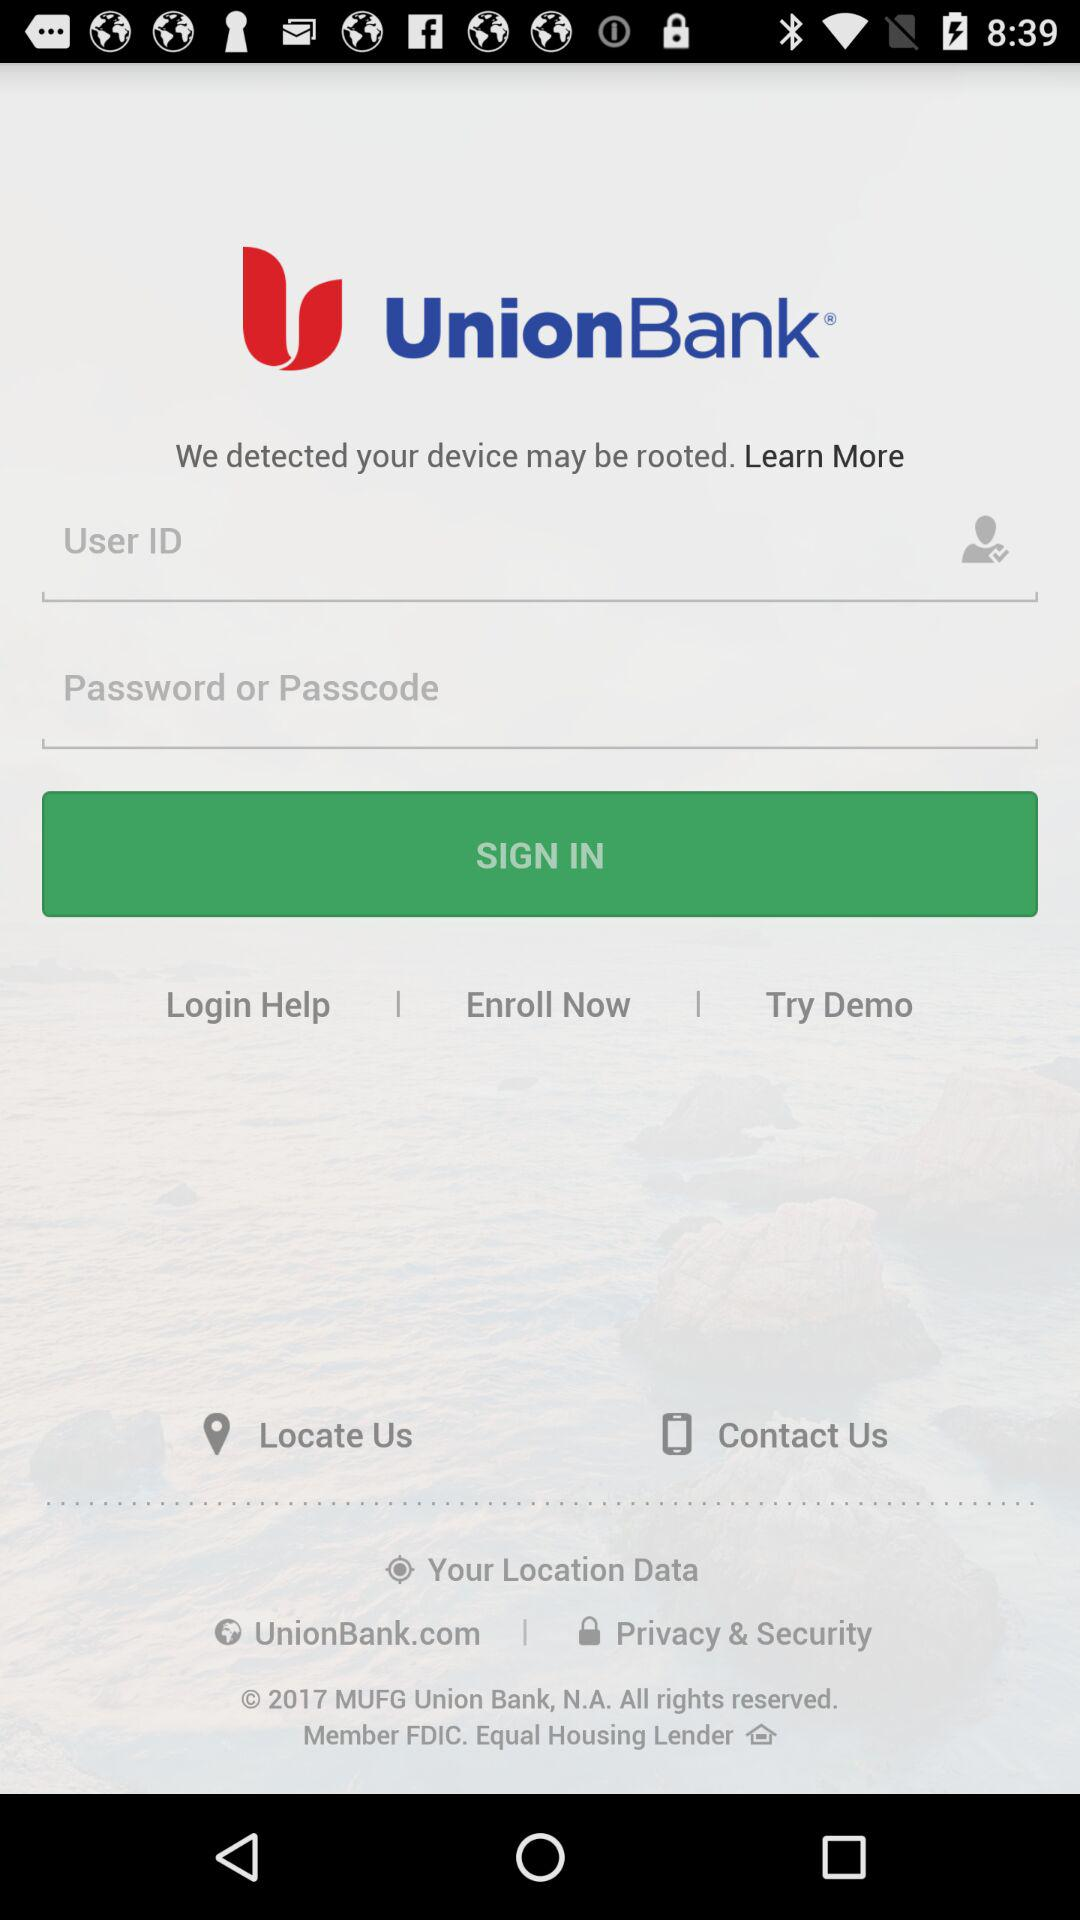How many text input fields are there on the screen?
Answer the question using a single word or phrase. 2 